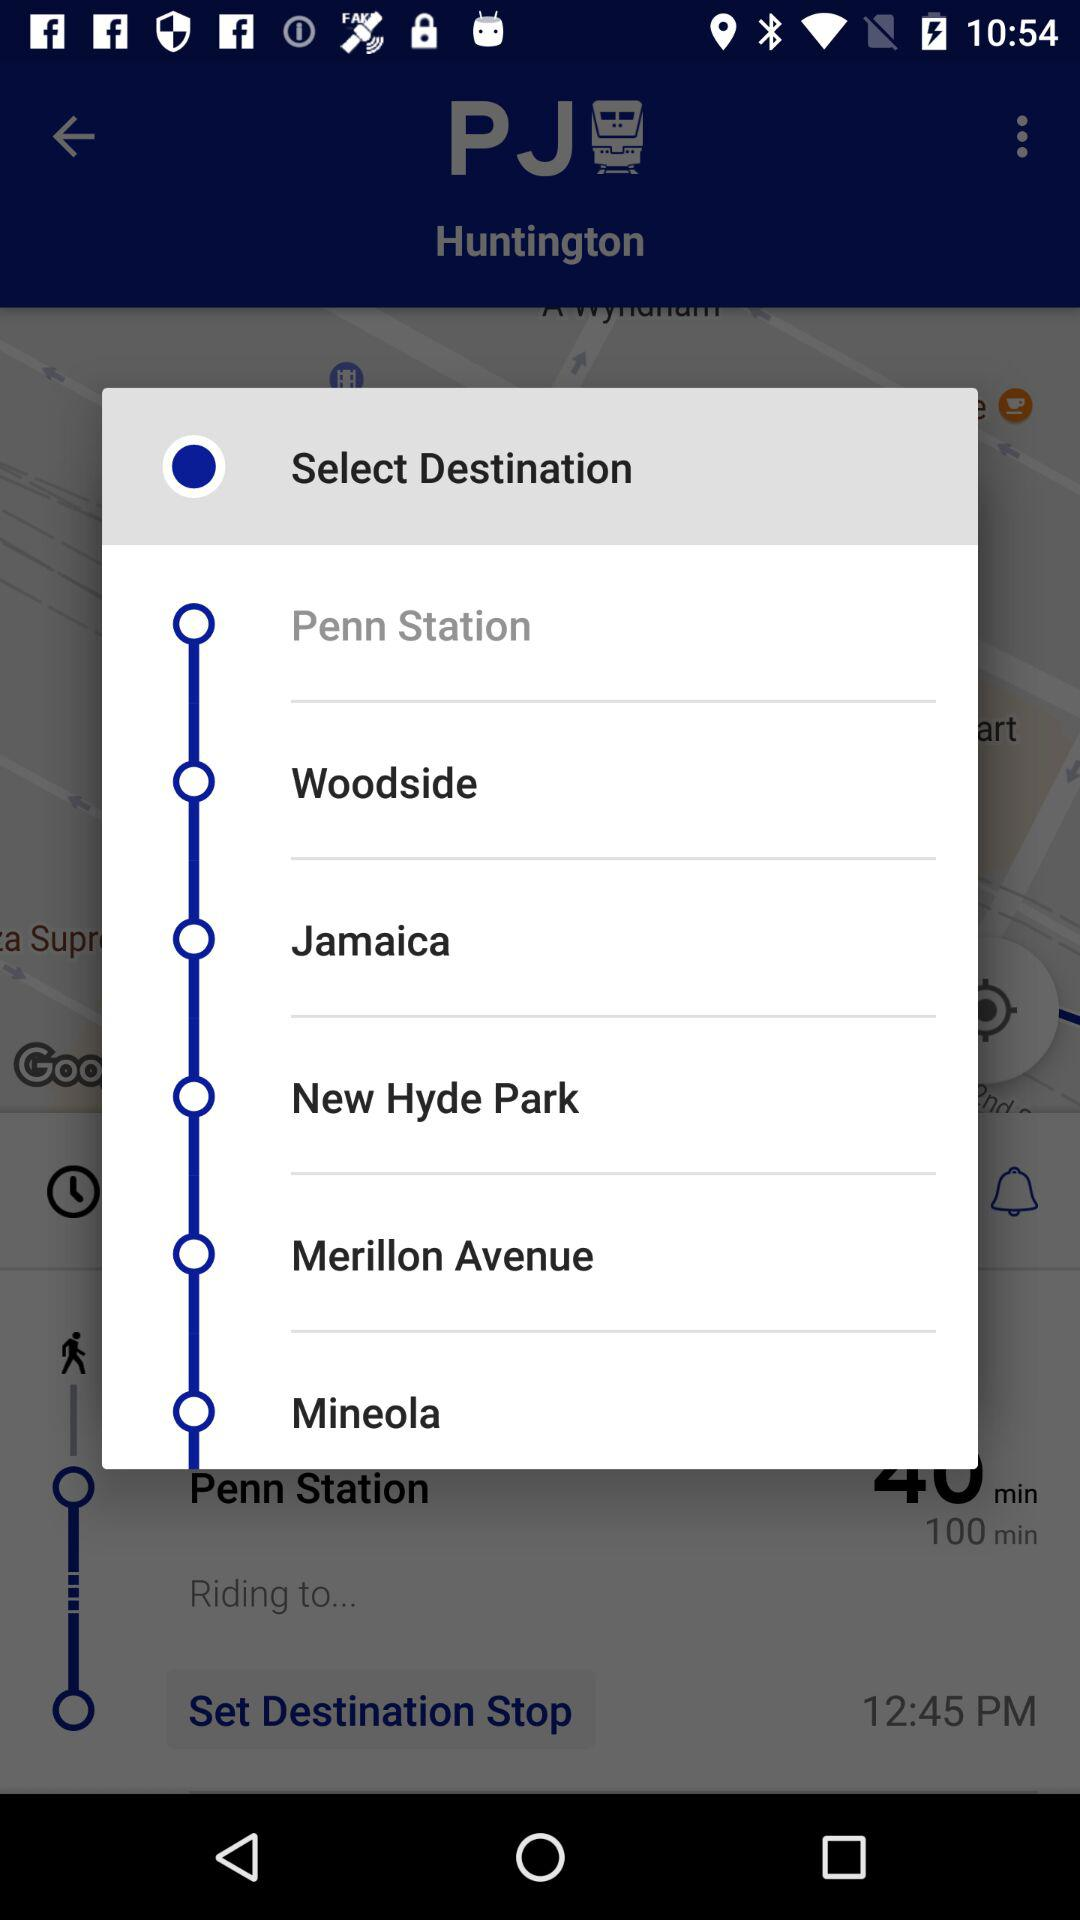How many destinations are there in total?
Answer the question using a single word or phrase. 6 